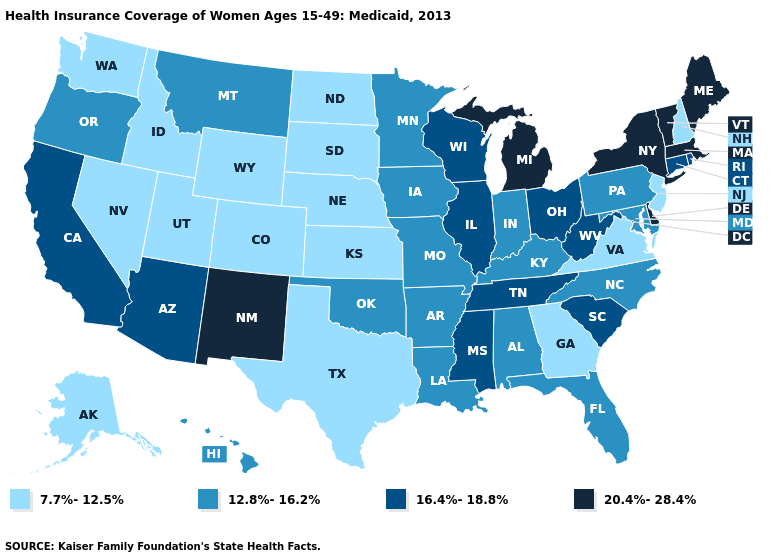Among the states that border Michigan , which have the highest value?
Be succinct. Ohio, Wisconsin. Among the states that border Oregon , which have the lowest value?
Short answer required. Idaho, Nevada, Washington. What is the highest value in states that border Kansas?
Answer briefly. 12.8%-16.2%. How many symbols are there in the legend?
Give a very brief answer. 4. Name the states that have a value in the range 20.4%-28.4%?
Concise answer only. Delaware, Maine, Massachusetts, Michigan, New Mexico, New York, Vermont. Name the states that have a value in the range 12.8%-16.2%?
Concise answer only. Alabama, Arkansas, Florida, Hawaii, Indiana, Iowa, Kentucky, Louisiana, Maryland, Minnesota, Missouri, Montana, North Carolina, Oklahoma, Oregon, Pennsylvania. Does Mississippi have a higher value than Indiana?
Be succinct. Yes. Name the states that have a value in the range 20.4%-28.4%?
Concise answer only. Delaware, Maine, Massachusetts, Michigan, New Mexico, New York, Vermont. Does Indiana have the highest value in the USA?
Quick response, please. No. What is the value of Arkansas?
Keep it brief. 12.8%-16.2%. Does New Mexico have the lowest value in the West?
Keep it brief. No. Name the states that have a value in the range 20.4%-28.4%?
Write a very short answer. Delaware, Maine, Massachusetts, Michigan, New Mexico, New York, Vermont. Does Maryland have the same value as Michigan?
Short answer required. No. What is the highest value in states that border Massachusetts?
Concise answer only. 20.4%-28.4%. Name the states that have a value in the range 12.8%-16.2%?
Write a very short answer. Alabama, Arkansas, Florida, Hawaii, Indiana, Iowa, Kentucky, Louisiana, Maryland, Minnesota, Missouri, Montana, North Carolina, Oklahoma, Oregon, Pennsylvania. 